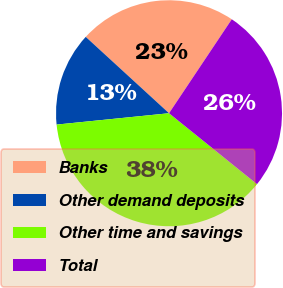Convert chart to OTSL. <chart><loc_0><loc_0><loc_500><loc_500><pie_chart><fcel>Banks<fcel>Other demand deposits<fcel>Other time and savings<fcel>Total<nl><fcel>22.56%<fcel>13.41%<fcel>37.6%<fcel>26.42%<nl></chart> 